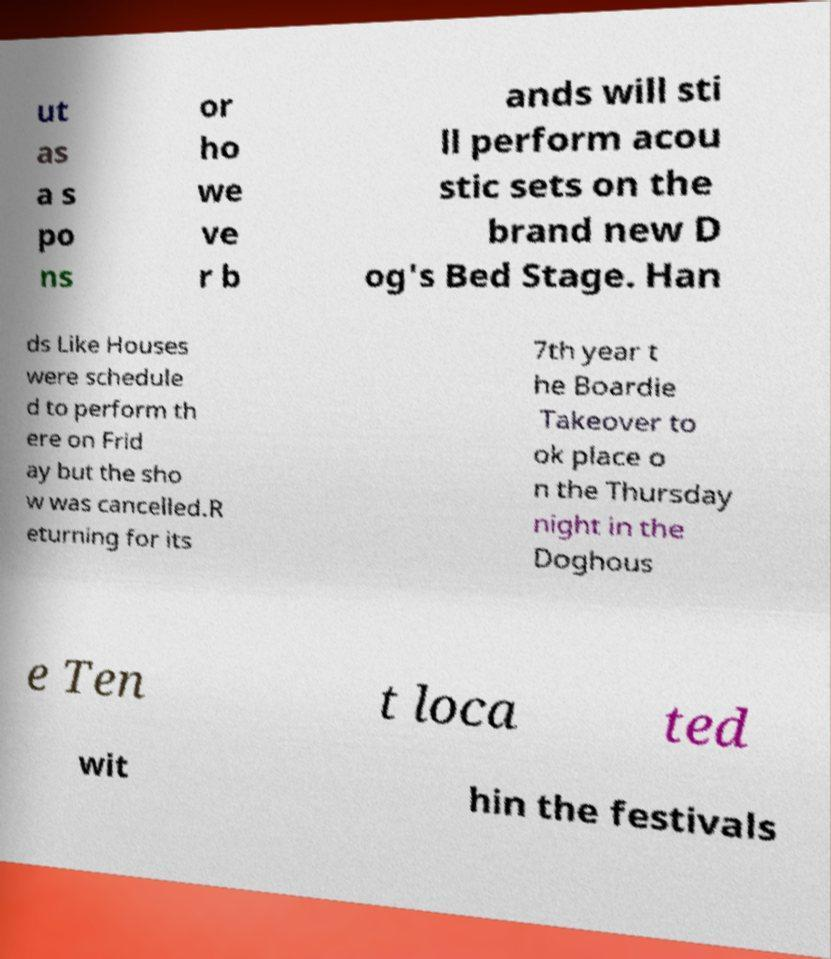Please read and relay the text visible in this image. What does it say? ut as a s po ns or ho we ve r b ands will sti ll perform acou stic sets on the brand new D og's Bed Stage. Han ds Like Houses were schedule d to perform th ere on Frid ay but the sho w was cancelled.R eturning for its 7th year t he Boardie Takeover to ok place o n the Thursday night in the Doghous e Ten t loca ted wit hin the festivals 